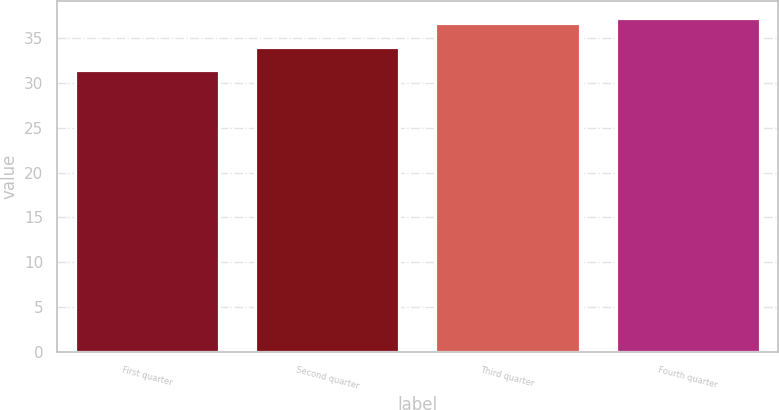Convert chart. <chart><loc_0><loc_0><loc_500><loc_500><bar_chart><fcel>First quarter<fcel>Second quarter<fcel>Third quarter<fcel>Fourth quarter<nl><fcel>31.42<fcel>33.99<fcel>36.72<fcel>37.3<nl></chart> 